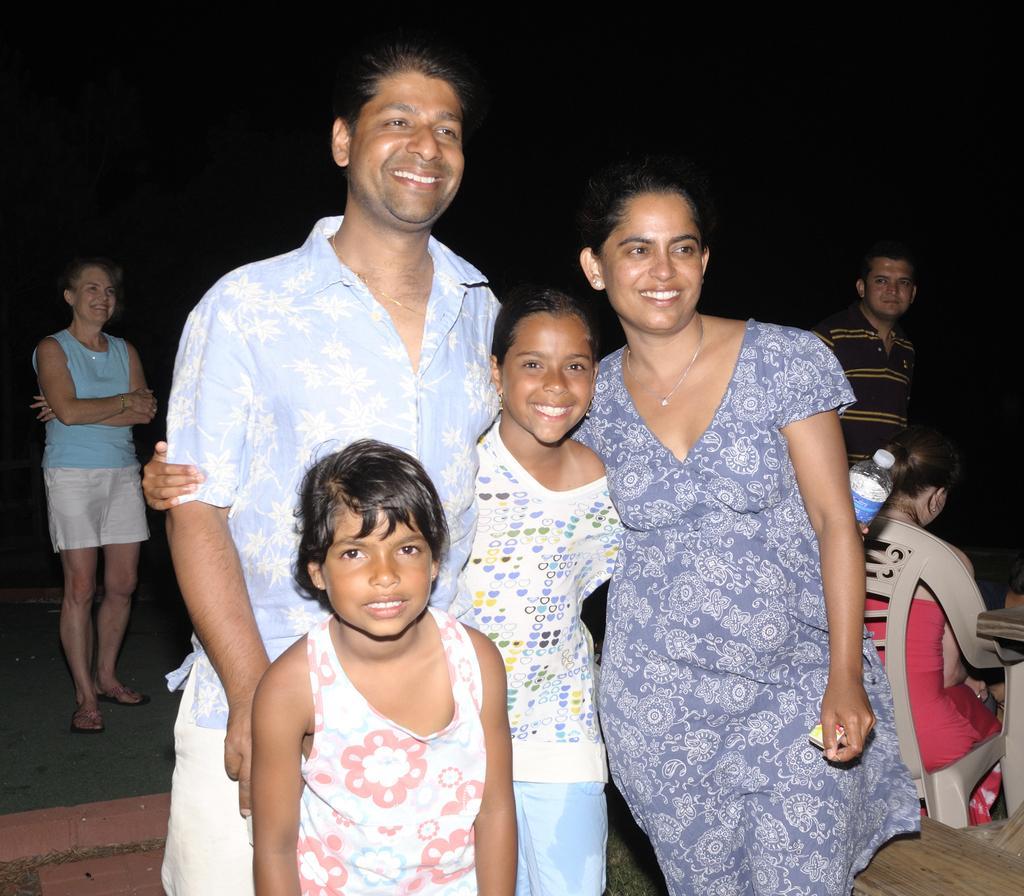In one or two sentences, can you explain what this image depicts? In the picture I can see a man, woman and two children are standing and smiling. Here I can see a person sitting on the chair, I can see two persons are standing and smiling and the background of the image is dark. 